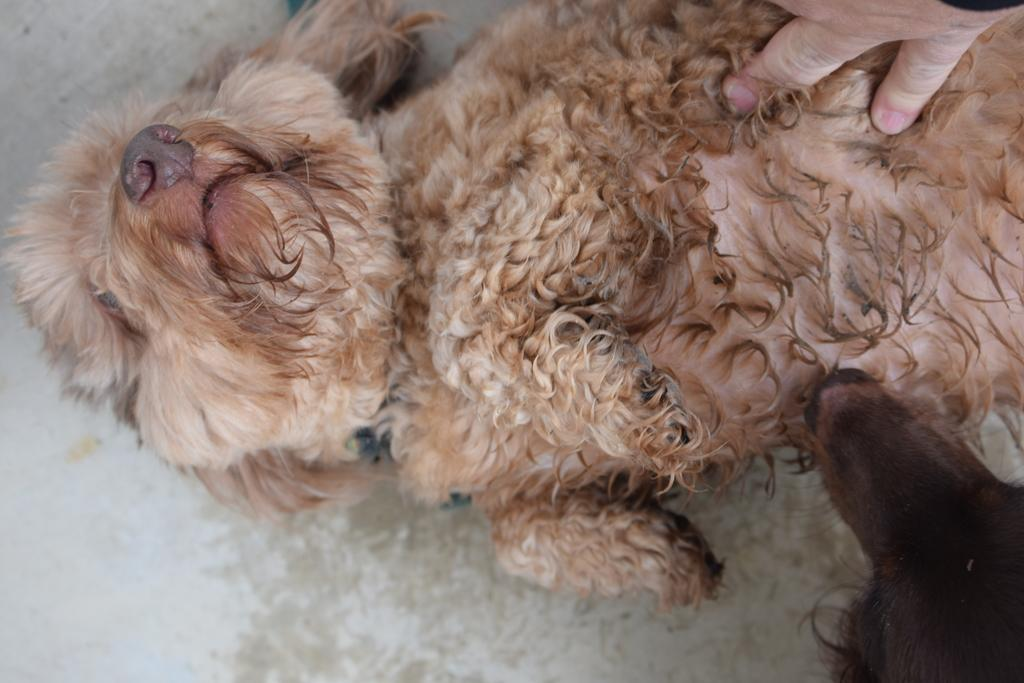How many dogs are present in the image? There are two dogs in the image. Can you describe any other elements in the image besides the dogs? Yes, there is a person's hand in the image. How many houses can be seen in the image? There are no houses present in the image; it only features two dogs and a person's hand. What type of beam is supporting the roof in the image? There is no roof or beam present in the image. 